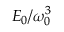Convert formula to latex. <formula><loc_0><loc_0><loc_500><loc_500>E _ { 0 } / \omega _ { 0 } ^ { 3 }</formula> 